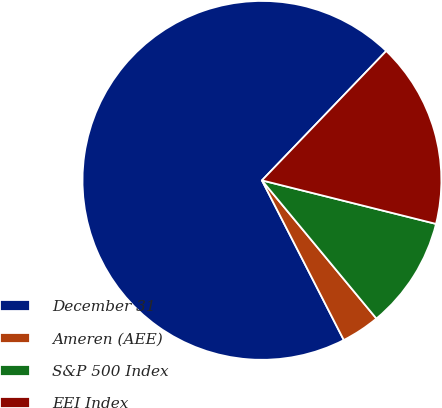Convert chart to OTSL. <chart><loc_0><loc_0><loc_500><loc_500><pie_chart><fcel>December 31<fcel>Ameren (AEE)<fcel>S&P 500 Index<fcel>EEI Index<nl><fcel>69.72%<fcel>3.47%<fcel>10.09%<fcel>16.72%<nl></chart> 